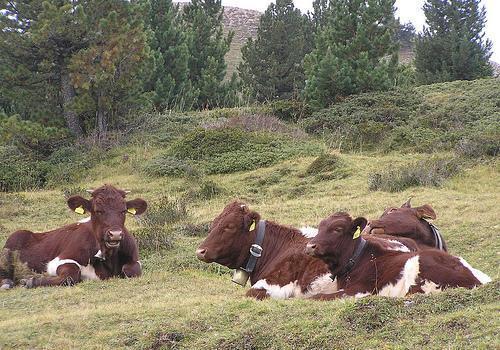How many cows are pictured?
Give a very brief answer. 4. How many cows are there?
Give a very brief answer. 4. 